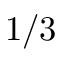<formula> <loc_0><loc_0><loc_500><loc_500>1 / 3</formula> 